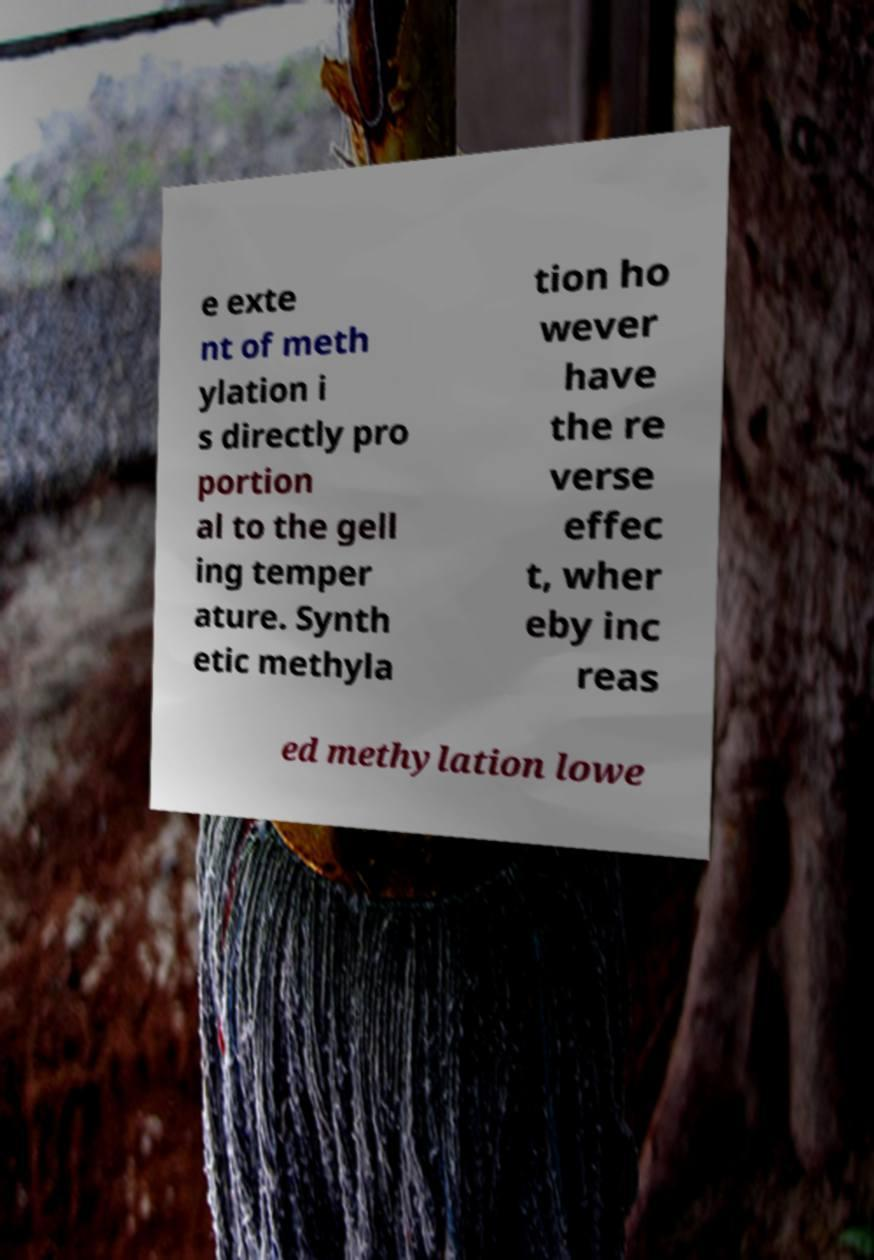I need the written content from this picture converted into text. Can you do that? e exte nt of meth ylation i s directly pro portion al to the gell ing temper ature. Synth etic methyla tion ho wever have the re verse effec t, wher eby inc reas ed methylation lowe 